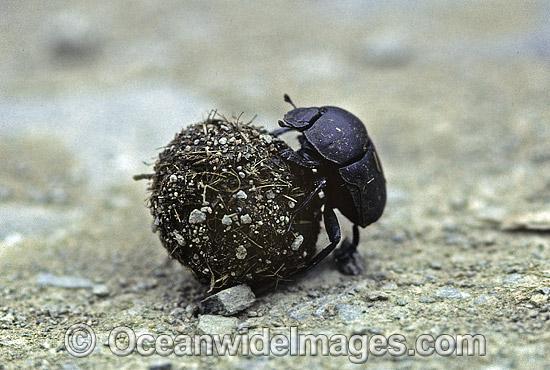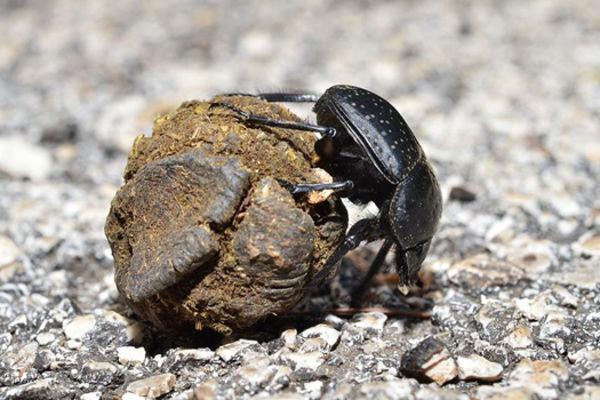The first image is the image on the left, the second image is the image on the right. For the images displayed, is the sentence "A dug beetle with a ball of dug is pictured in black and white." factually correct? Answer yes or no. No. The first image is the image on the left, the second image is the image on the right. For the images displayed, is the sentence "In one image there is a dung beetle on the right side of the dung ball with its head toward the ground." factually correct? Answer yes or no. Yes. 